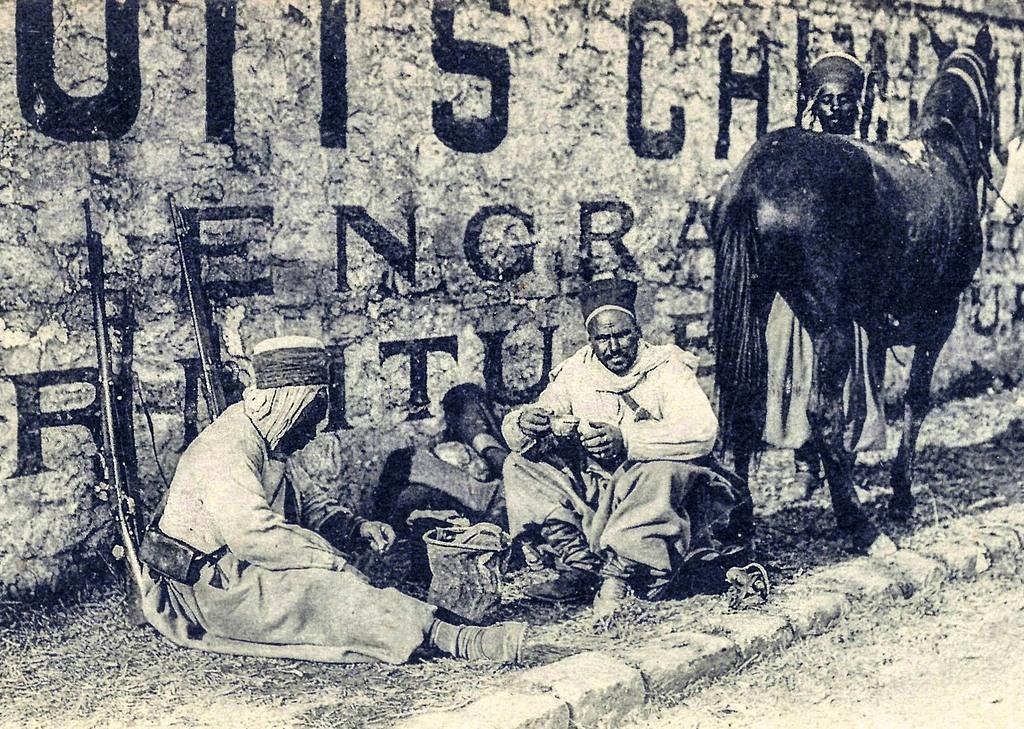Describe this image in one or two sentences. As we can see in the image there is a wall, black color horse and few people here and there. 